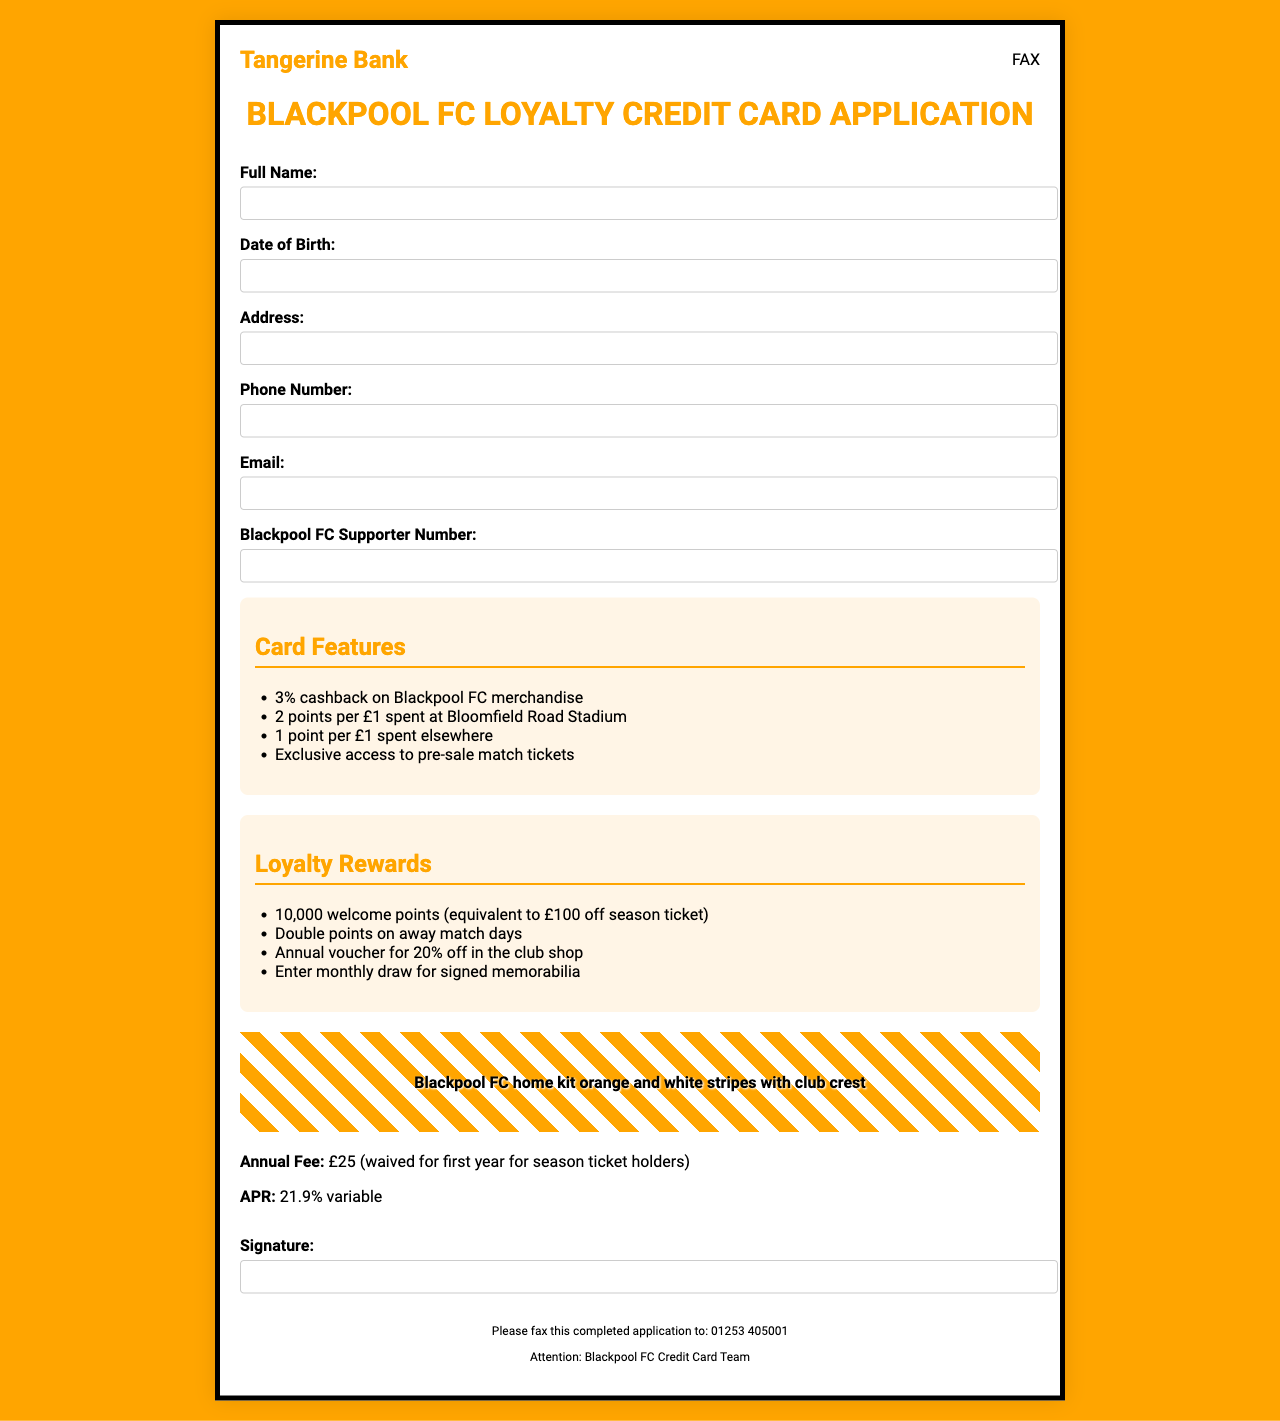what is the annual fee for the credit card? The annual fee is stated as £25, which can be waived for certain holders.
Answer: £25 what is the APR for the credit card? The APR is clearly indicated in the document.
Answer: 21.9% variable how many welcome points are given upon approval? The document specifies the number of welcome points offered to new cardholders.
Answer: 10,000 where should the completed application be faxed? The fax number is provided in the footer section of the document.
Answer: 01253 405001 what is one of the loyalty rewards offered? The document lists various rewards, and one example can be taken from it.
Answer: 20% off in the club shop how many points are earned per £1 spent at Bloomfield Road Stadium? The specifics regarding point accumulation for spending are detailed in the features section.
Answer: 2 points per £1 what is required in the "Blackpool FC Supporter Number" field? This field requests specific information from the applicant related to their supporter status.
Answer: Supporter Number what is the benefit for season ticket holders regarding the annual fee? The document mentions a special condition for season ticket holders related to the fee.
Answer: Waived for first year 